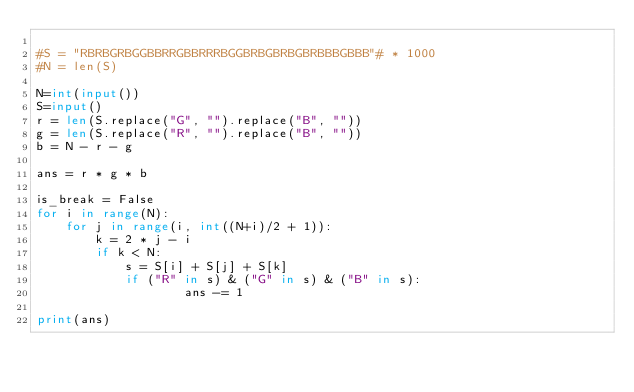<code> <loc_0><loc_0><loc_500><loc_500><_Python_>
#S = "RBRBGRBGGBBRRGBBRRRBGGBRBGBRBGBRBBBGBBB"# * 1000
#N = len(S)

N=int(input())
S=input()
r = len(S.replace("G", "").replace("B", ""))
g = len(S.replace("R", "").replace("B", ""))
b = N - r - g
 
ans = r * g * b
 
is_break = False
for i in range(N):
    for j in range(i, int((N+i)/2 + 1)):
        k = 2 * j - i
        if k < N:
            s = S[i] + S[j] + S[k]
            if ("R" in s) & ("G" in s) & ("B" in s):
                    ans -= 1

print(ans)
</code> 